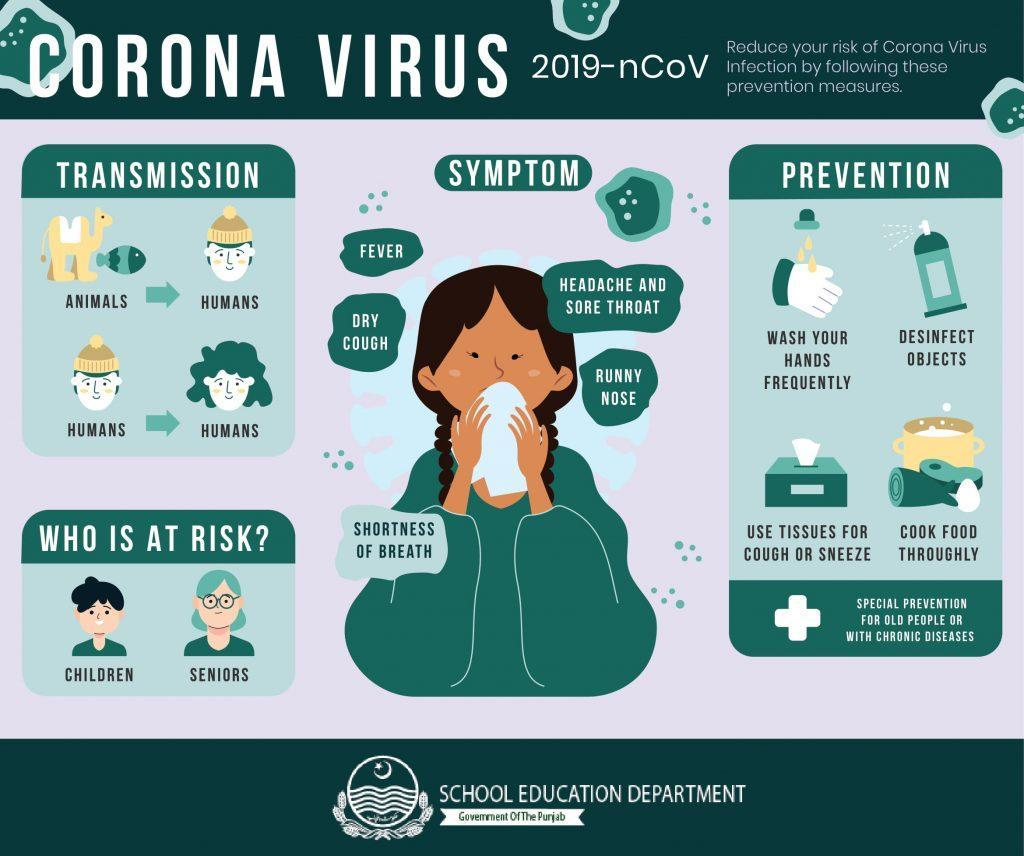How many people are shown in the infographic?
Answer the question with a short phrase. 6 